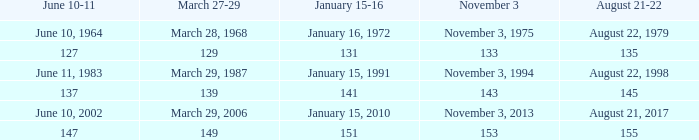What number is shown for january 15-16 when november 3 is 133? 131.0. 